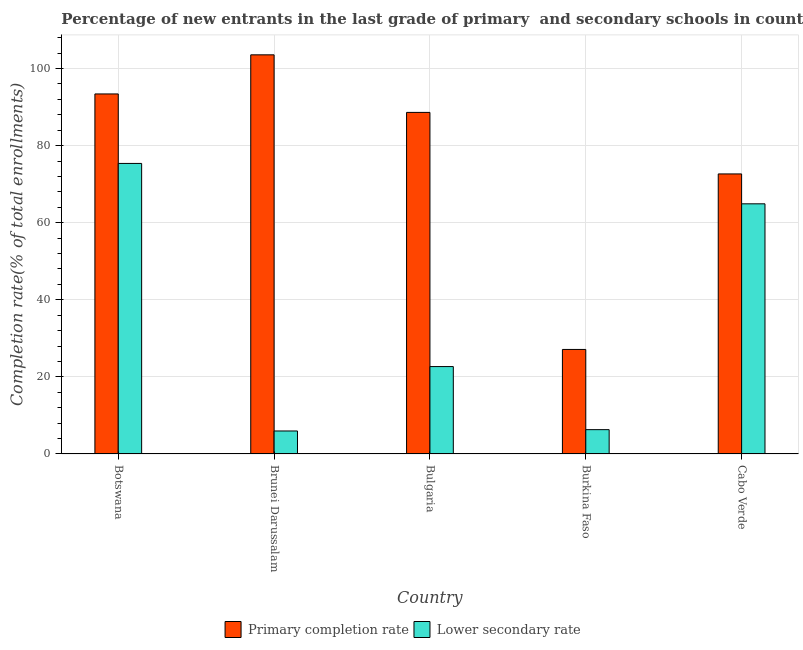Are the number of bars per tick equal to the number of legend labels?
Provide a short and direct response. Yes. Are the number of bars on each tick of the X-axis equal?
Give a very brief answer. Yes. What is the label of the 2nd group of bars from the left?
Your answer should be compact. Brunei Darussalam. What is the completion rate in secondary schools in Bulgaria?
Make the answer very short. 22.67. Across all countries, what is the maximum completion rate in secondary schools?
Your answer should be compact. 75.37. Across all countries, what is the minimum completion rate in secondary schools?
Keep it short and to the point. 5.97. In which country was the completion rate in primary schools maximum?
Your answer should be very brief. Brunei Darussalam. In which country was the completion rate in secondary schools minimum?
Provide a succinct answer. Brunei Darussalam. What is the total completion rate in primary schools in the graph?
Keep it short and to the point. 385.33. What is the difference between the completion rate in secondary schools in Brunei Darussalam and that in Burkina Faso?
Your answer should be very brief. -0.34. What is the difference between the completion rate in secondary schools in Bulgaria and the completion rate in primary schools in Cabo Verde?
Give a very brief answer. -49.98. What is the average completion rate in secondary schools per country?
Your answer should be very brief. 35.04. What is the difference between the completion rate in primary schools and completion rate in secondary schools in Bulgaria?
Your answer should be compact. 65.94. In how many countries, is the completion rate in secondary schools greater than 72 %?
Make the answer very short. 1. What is the ratio of the completion rate in secondary schools in Botswana to that in Bulgaria?
Give a very brief answer. 3.32. What is the difference between the highest and the second highest completion rate in secondary schools?
Provide a succinct answer. 10.48. What is the difference between the highest and the lowest completion rate in secondary schools?
Offer a terse response. 69.41. In how many countries, is the completion rate in primary schools greater than the average completion rate in primary schools taken over all countries?
Provide a short and direct response. 3. What does the 1st bar from the left in Brunei Darussalam represents?
Provide a succinct answer. Primary completion rate. What does the 1st bar from the right in Cabo Verde represents?
Offer a very short reply. Lower secondary rate. How many bars are there?
Your answer should be very brief. 10. How many countries are there in the graph?
Provide a succinct answer. 5. Does the graph contain any zero values?
Keep it short and to the point. No. Where does the legend appear in the graph?
Offer a terse response. Bottom center. What is the title of the graph?
Make the answer very short. Percentage of new entrants in the last grade of primary  and secondary schools in countries. What is the label or title of the Y-axis?
Offer a terse response. Completion rate(% of total enrollments). What is the Completion rate(% of total enrollments) of Primary completion rate in Botswana?
Make the answer very short. 93.4. What is the Completion rate(% of total enrollments) in Lower secondary rate in Botswana?
Your response must be concise. 75.37. What is the Completion rate(% of total enrollments) of Primary completion rate in Brunei Darussalam?
Offer a very short reply. 103.55. What is the Completion rate(% of total enrollments) of Lower secondary rate in Brunei Darussalam?
Offer a very short reply. 5.97. What is the Completion rate(% of total enrollments) of Primary completion rate in Bulgaria?
Provide a succinct answer. 88.61. What is the Completion rate(% of total enrollments) in Lower secondary rate in Bulgaria?
Offer a terse response. 22.67. What is the Completion rate(% of total enrollments) of Primary completion rate in Burkina Faso?
Offer a very short reply. 27.12. What is the Completion rate(% of total enrollments) of Lower secondary rate in Burkina Faso?
Provide a succinct answer. 6.31. What is the Completion rate(% of total enrollments) in Primary completion rate in Cabo Verde?
Offer a terse response. 72.65. What is the Completion rate(% of total enrollments) in Lower secondary rate in Cabo Verde?
Offer a very short reply. 64.9. Across all countries, what is the maximum Completion rate(% of total enrollments) in Primary completion rate?
Keep it short and to the point. 103.55. Across all countries, what is the maximum Completion rate(% of total enrollments) in Lower secondary rate?
Offer a terse response. 75.37. Across all countries, what is the minimum Completion rate(% of total enrollments) in Primary completion rate?
Offer a terse response. 27.12. Across all countries, what is the minimum Completion rate(% of total enrollments) of Lower secondary rate?
Offer a terse response. 5.97. What is the total Completion rate(% of total enrollments) in Primary completion rate in the graph?
Give a very brief answer. 385.33. What is the total Completion rate(% of total enrollments) in Lower secondary rate in the graph?
Make the answer very short. 175.22. What is the difference between the Completion rate(% of total enrollments) in Primary completion rate in Botswana and that in Brunei Darussalam?
Offer a very short reply. -10.15. What is the difference between the Completion rate(% of total enrollments) of Lower secondary rate in Botswana and that in Brunei Darussalam?
Your answer should be very brief. 69.41. What is the difference between the Completion rate(% of total enrollments) in Primary completion rate in Botswana and that in Bulgaria?
Give a very brief answer. 4.79. What is the difference between the Completion rate(% of total enrollments) in Lower secondary rate in Botswana and that in Bulgaria?
Your answer should be compact. 52.7. What is the difference between the Completion rate(% of total enrollments) of Primary completion rate in Botswana and that in Burkina Faso?
Offer a very short reply. 66.28. What is the difference between the Completion rate(% of total enrollments) of Lower secondary rate in Botswana and that in Burkina Faso?
Offer a very short reply. 69.06. What is the difference between the Completion rate(% of total enrollments) in Primary completion rate in Botswana and that in Cabo Verde?
Your answer should be compact. 20.75. What is the difference between the Completion rate(% of total enrollments) of Lower secondary rate in Botswana and that in Cabo Verde?
Make the answer very short. 10.48. What is the difference between the Completion rate(% of total enrollments) of Primary completion rate in Brunei Darussalam and that in Bulgaria?
Provide a short and direct response. 14.93. What is the difference between the Completion rate(% of total enrollments) of Lower secondary rate in Brunei Darussalam and that in Bulgaria?
Make the answer very short. -16.71. What is the difference between the Completion rate(% of total enrollments) of Primary completion rate in Brunei Darussalam and that in Burkina Faso?
Provide a succinct answer. 76.43. What is the difference between the Completion rate(% of total enrollments) in Lower secondary rate in Brunei Darussalam and that in Burkina Faso?
Keep it short and to the point. -0.34. What is the difference between the Completion rate(% of total enrollments) in Primary completion rate in Brunei Darussalam and that in Cabo Verde?
Provide a short and direct response. 30.9. What is the difference between the Completion rate(% of total enrollments) in Lower secondary rate in Brunei Darussalam and that in Cabo Verde?
Provide a short and direct response. -58.93. What is the difference between the Completion rate(% of total enrollments) in Primary completion rate in Bulgaria and that in Burkina Faso?
Your answer should be very brief. 61.5. What is the difference between the Completion rate(% of total enrollments) in Lower secondary rate in Bulgaria and that in Burkina Faso?
Offer a very short reply. 16.36. What is the difference between the Completion rate(% of total enrollments) in Primary completion rate in Bulgaria and that in Cabo Verde?
Offer a terse response. 15.96. What is the difference between the Completion rate(% of total enrollments) in Lower secondary rate in Bulgaria and that in Cabo Verde?
Ensure brevity in your answer.  -42.22. What is the difference between the Completion rate(% of total enrollments) in Primary completion rate in Burkina Faso and that in Cabo Verde?
Give a very brief answer. -45.53. What is the difference between the Completion rate(% of total enrollments) in Lower secondary rate in Burkina Faso and that in Cabo Verde?
Keep it short and to the point. -58.59. What is the difference between the Completion rate(% of total enrollments) in Primary completion rate in Botswana and the Completion rate(% of total enrollments) in Lower secondary rate in Brunei Darussalam?
Your answer should be compact. 87.44. What is the difference between the Completion rate(% of total enrollments) of Primary completion rate in Botswana and the Completion rate(% of total enrollments) of Lower secondary rate in Bulgaria?
Keep it short and to the point. 70.73. What is the difference between the Completion rate(% of total enrollments) in Primary completion rate in Botswana and the Completion rate(% of total enrollments) in Lower secondary rate in Burkina Faso?
Ensure brevity in your answer.  87.09. What is the difference between the Completion rate(% of total enrollments) of Primary completion rate in Botswana and the Completion rate(% of total enrollments) of Lower secondary rate in Cabo Verde?
Give a very brief answer. 28.5. What is the difference between the Completion rate(% of total enrollments) of Primary completion rate in Brunei Darussalam and the Completion rate(% of total enrollments) of Lower secondary rate in Bulgaria?
Offer a terse response. 80.87. What is the difference between the Completion rate(% of total enrollments) of Primary completion rate in Brunei Darussalam and the Completion rate(% of total enrollments) of Lower secondary rate in Burkina Faso?
Offer a terse response. 97.24. What is the difference between the Completion rate(% of total enrollments) in Primary completion rate in Brunei Darussalam and the Completion rate(% of total enrollments) in Lower secondary rate in Cabo Verde?
Give a very brief answer. 38.65. What is the difference between the Completion rate(% of total enrollments) of Primary completion rate in Bulgaria and the Completion rate(% of total enrollments) of Lower secondary rate in Burkina Faso?
Offer a terse response. 82.3. What is the difference between the Completion rate(% of total enrollments) of Primary completion rate in Bulgaria and the Completion rate(% of total enrollments) of Lower secondary rate in Cabo Verde?
Provide a succinct answer. 23.72. What is the difference between the Completion rate(% of total enrollments) in Primary completion rate in Burkina Faso and the Completion rate(% of total enrollments) in Lower secondary rate in Cabo Verde?
Keep it short and to the point. -37.78. What is the average Completion rate(% of total enrollments) in Primary completion rate per country?
Provide a short and direct response. 77.07. What is the average Completion rate(% of total enrollments) in Lower secondary rate per country?
Your response must be concise. 35.04. What is the difference between the Completion rate(% of total enrollments) of Primary completion rate and Completion rate(% of total enrollments) of Lower secondary rate in Botswana?
Keep it short and to the point. 18.03. What is the difference between the Completion rate(% of total enrollments) of Primary completion rate and Completion rate(% of total enrollments) of Lower secondary rate in Brunei Darussalam?
Offer a terse response. 97.58. What is the difference between the Completion rate(% of total enrollments) of Primary completion rate and Completion rate(% of total enrollments) of Lower secondary rate in Bulgaria?
Keep it short and to the point. 65.94. What is the difference between the Completion rate(% of total enrollments) in Primary completion rate and Completion rate(% of total enrollments) in Lower secondary rate in Burkina Faso?
Offer a very short reply. 20.81. What is the difference between the Completion rate(% of total enrollments) of Primary completion rate and Completion rate(% of total enrollments) of Lower secondary rate in Cabo Verde?
Offer a very short reply. 7.75. What is the ratio of the Completion rate(% of total enrollments) of Primary completion rate in Botswana to that in Brunei Darussalam?
Give a very brief answer. 0.9. What is the ratio of the Completion rate(% of total enrollments) in Lower secondary rate in Botswana to that in Brunei Darussalam?
Offer a terse response. 12.63. What is the ratio of the Completion rate(% of total enrollments) in Primary completion rate in Botswana to that in Bulgaria?
Offer a very short reply. 1.05. What is the ratio of the Completion rate(% of total enrollments) in Lower secondary rate in Botswana to that in Bulgaria?
Offer a terse response. 3.32. What is the ratio of the Completion rate(% of total enrollments) in Primary completion rate in Botswana to that in Burkina Faso?
Ensure brevity in your answer.  3.44. What is the ratio of the Completion rate(% of total enrollments) in Lower secondary rate in Botswana to that in Burkina Faso?
Offer a very short reply. 11.94. What is the ratio of the Completion rate(% of total enrollments) in Primary completion rate in Botswana to that in Cabo Verde?
Keep it short and to the point. 1.29. What is the ratio of the Completion rate(% of total enrollments) in Lower secondary rate in Botswana to that in Cabo Verde?
Your response must be concise. 1.16. What is the ratio of the Completion rate(% of total enrollments) of Primary completion rate in Brunei Darussalam to that in Bulgaria?
Provide a succinct answer. 1.17. What is the ratio of the Completion rate(% of total enrollments) of Lower secondary rate in Brunei Darussalam to that in Bulgaria?
Make the answer very short. 0.26. What is the ratio of the Completion rate(% of total enrollments) of Primary completion rate in Brunei Darussalam to that in Burkina Faso?
Your answer should be very brief. 3.82. What is the ratio of the Completion rate(% of total enrollments) in Lower secondary rate in Brunei Darussalam to that in Burkina Faso?
Your answer should be very brief. 0.95. What is the ratio of the Completion rate(% of total enrollments) of Primary completion rate in Brunei Darussalam to that in Cabo Verde?
Your response must be concise. 1.43. What is the ratio of the Completion rate(% of total enrollments) in Lower secondary rate in Brunei Darussalam to that in Cabo Verde?
Make the answer very short. 0.09. What is the ratio of the Completion rate(% of total enrollments) in Primary completion rate in Bulgaria to that in Burkina Faso?
Your answer should be very brief. 3.27. What is the ratio of the Completion rate(% of total enrollments) in Lower secondary rate in Bulgaria to that in Burkina Faso?
Provide a succinct answer. 3.59. What is the ratio of the Completion rate(% of total enrollments) of Primary completion rate in Bulgaria to that in Cabo Verde?
Your response must be concise. 1.22. What is the ratio of the Completion rate(% of total enrollments) of Lower secondary rate in Bulgaria to that in Cabo Verde?
Keep it short and to the point. 0.35. What is the ratio of the Completion rate(% of total enrollments) of Primary completion rate in Burkina Faso to that in Cabo Verde?
Your answer should be very brief. 0.37. What is the ratio of the Completion rate(% of total enrollments) in Lower secondary rate in Burkina Faso to that in Cabo Verde?
Keep it short and to the point. 0.1. What is the difference between the highest and the second highest Completion rate(% of total enrollments) in Primary completion rate?
Ensure brevity in your answer.  10.15. What is the difference between the highest and the second highest Completion rate(% of total enrollments) in Lower secondary rate?
Make the answer very short. 10.48. What is the difference between the highest and the lowest Completion rate(% of total enrollments) in Primary completion rate?
Provide a succinct answer. 76.43. What is the difference between the highest and the lowest Completion rate(% of total enrollments) in Lower secondary rate?
Ensure brevity in your answer.  69.41. 